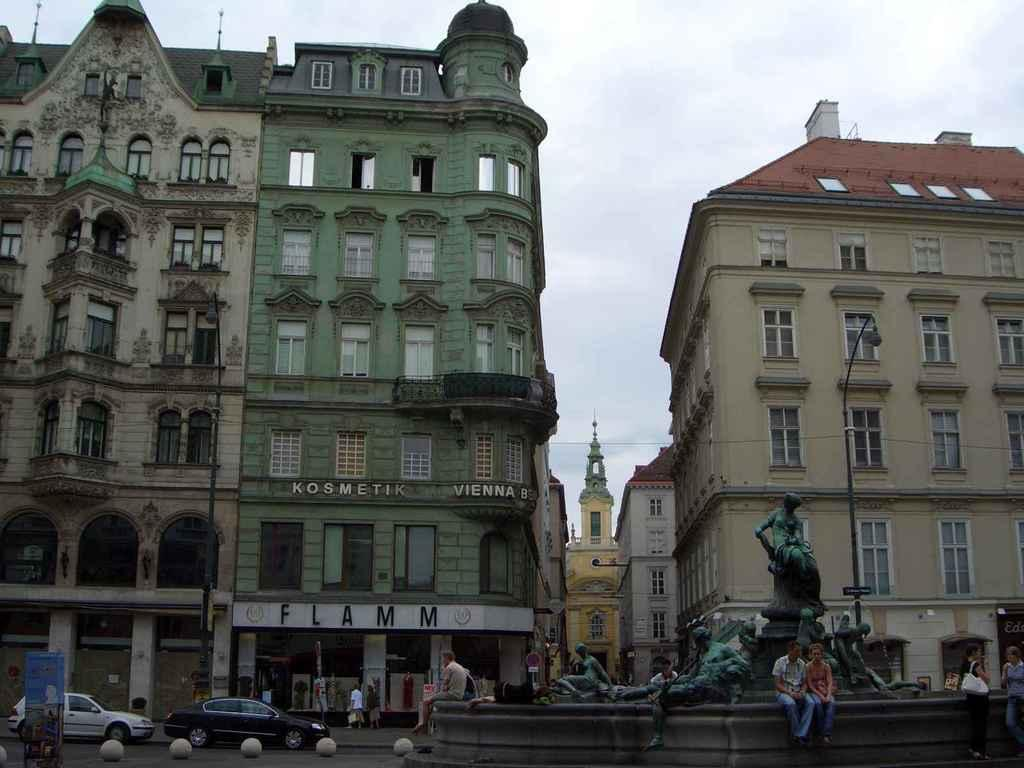<image>
Share a concise interpretation of the image provided. A fountain sits in the foreground of a few tall buildings one of which is a Kosmetik Vienna building. 